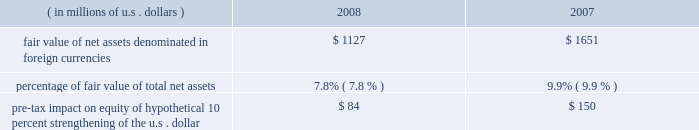Foreign currency exchange rate risk many of our non-u.s .
Companies maintain both assets and liabilities in local currencies .
Therefore , foreign exchange rate risk is generally limited to net assets denominated in those foreign currencies .
Foreign exchange rate risk is reviewed as part of our risk management process .
Locally required capital levels are invested in home currencies in order to satisfy regulatory require- ments and to support local insurance operations regardless of currency fluctuations .
The principal currencies creating foreign exchange risk for us are the british pound sterling , the euro , and the canadian dollar .
The table provides more information on our exposure to foreign exchange rate risk at december 31 , 2008 and 2007. .
Reinsurance of gmdb and gmib guarantees our net income is directly impacted by changes in the reserves calculated in connection with the reinsurance of variable annuity guarantees , primarily gmdb and gmib .
These reserves are calculated in accordance with sop 03-1 ( sop reserves ) and changes in these reserves are reflected as life and annuity benefit expense , which is included in life underwriting income .
In addition , our net income is directly impacted by the change in the fair value of the gmib liability ( fvl ) , which is classified as a derivative according to fas 133 .
The fair value liability established for a gmib reinsurance contract represents the differ- ence between the fair value of the contract and the sop 03-1 reserves .
Changes in the fair value of the gmib liability , net of associated changes in the calculated sop 03-1 reserve , are reflected as realized gains or losses .
Ace views our variable annuity reinsurance business as having a similar risk profile to that of catastrophe reinsurance , with the probability of long-term economic loss relatively small at the time of pricing .
Adverse changes in market factors and policyholder behavior will have an impact on both life underwriting income and net income .
When evaluating these risks , we expect to be compensated for taking both the risk of a cumulative long-term economic net loss , as well as the short-term accounting variations caused by these market movements .
Therefore , we evaluate this business in terms of its long-term eco- nomic risk and reward .
The ultimate risk to the variable annuity guaranty reinsurance business is a long-term underperformance of investment returns , which can be exacerbated by a long-term reduction in interest rates .
Following a market downturn , continued market underperformance over a period of five to seven years would eventually result in a higher level of paid claims as policyholders accessed their guarantees through death or annuitization .
However , if market conditions improved following a downturn , sop 03-1 reserves and fair value liability would fall reflecting a decreased likelihood of future claims , which would result in an increase in both life underwriting income and net income .
As of december 31 , 2008 , management established the sop 03-1 reserve based on the benefit ratio calculated using actual market values at december 31 , 2008 .
Management exercises judgment in determining the extent to which short-term market movements impact the sop 03-1 reserve .
The sop 03-1 reserve is based on the calculation of a long-term benefit ratio ( or loss ratio ) for the variable annuity guarantee reinsurance .
Despite the long-term nature of the risk the benefit ratio calculation is impacted by short-term market movements that may be judged by management to be temporary or transient .
Management will , in keeping with the language in sop 03-1 , regularly examine both quantitative and qualitative analysis and management will determine if , in its judgment , the change in the calculated benefit ratio is of sufficient magnitude and has persisted for a sufficient duration to warrant a change in the benefit ratio used to establish the sop 03-1 reserve .
This has no impact on either premium received or claims paid nor does it impact the long-term profit or loss of the variable annuity guaran- tee reinsurance .
The sop 03-1 reserve and fair value liability calculations are directly affected by market factors , including equity levels , interest rate levels , credit risk and implied volatilities , as well as policyholder behaviors , such as annuitization and lapse rates .
The table below shows the sensitivity , as of december 31 , 2008 , of the sop 03-1 reserves and fair value liability associated with the variable annuity guarantee reinsurance portfolio .
In addition , the tables below show the sensitivity of the fair value of specific derivative instruments held ( hedge value ) , which includes instruments purchased in january 2009 , to partially offset the risk in the variable annuity guarantee reinsurance portfolio .
Although these derivatives do not receive hedge accounting treatment , some portion of the change in value may be used to offset changes in the sop 03-1 reserve. .
What was the ratio of the pre-tax impact on equity of hypothetical 10 percent strengthening of the u.s . dollar in 2007 to 2008? 
Computations: (150 / 84)
Answer: 1.78571. 